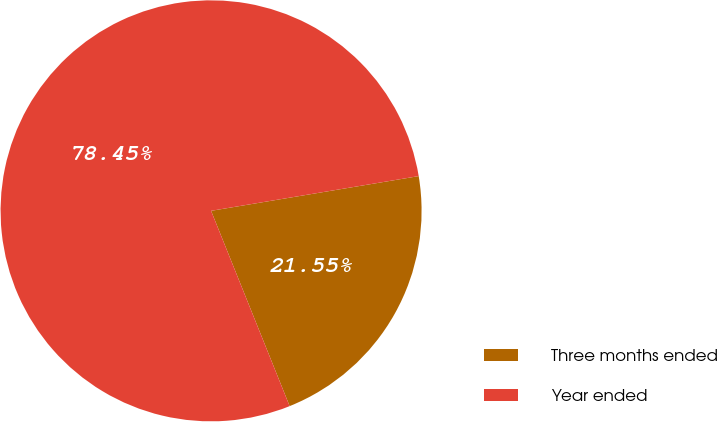Convert chart. <chart><loc_0><loc_0><loc_500><loc_500><pie_chart><fcel>Three months ended<fcel>Year ended<nl><fcel>21.55%<fcel>78.45%<nl></chart> 